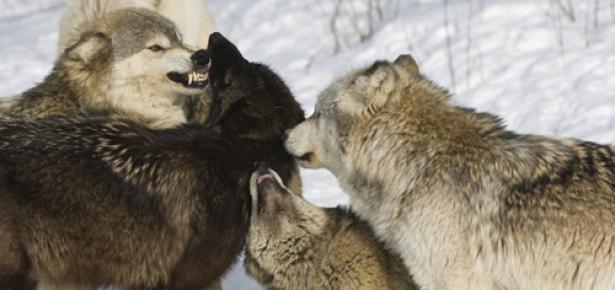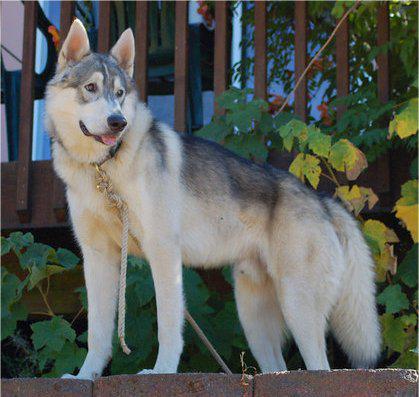The first image is the image on the left, the second image is the image on the right. For the images shown, is this caption "There is a single dog with its mouth open in the right image." true? Answer yes or no. Yes. The first image is the image on the left, the second image is the image on the right. For the images displayed, is the sentence "The foreground of the right image features an open-mouthed husky with a curled, upturned tail standing in profile facing leftward, withone front paw slightly bent and lifted." factually correct? Answer yes or no. No. 